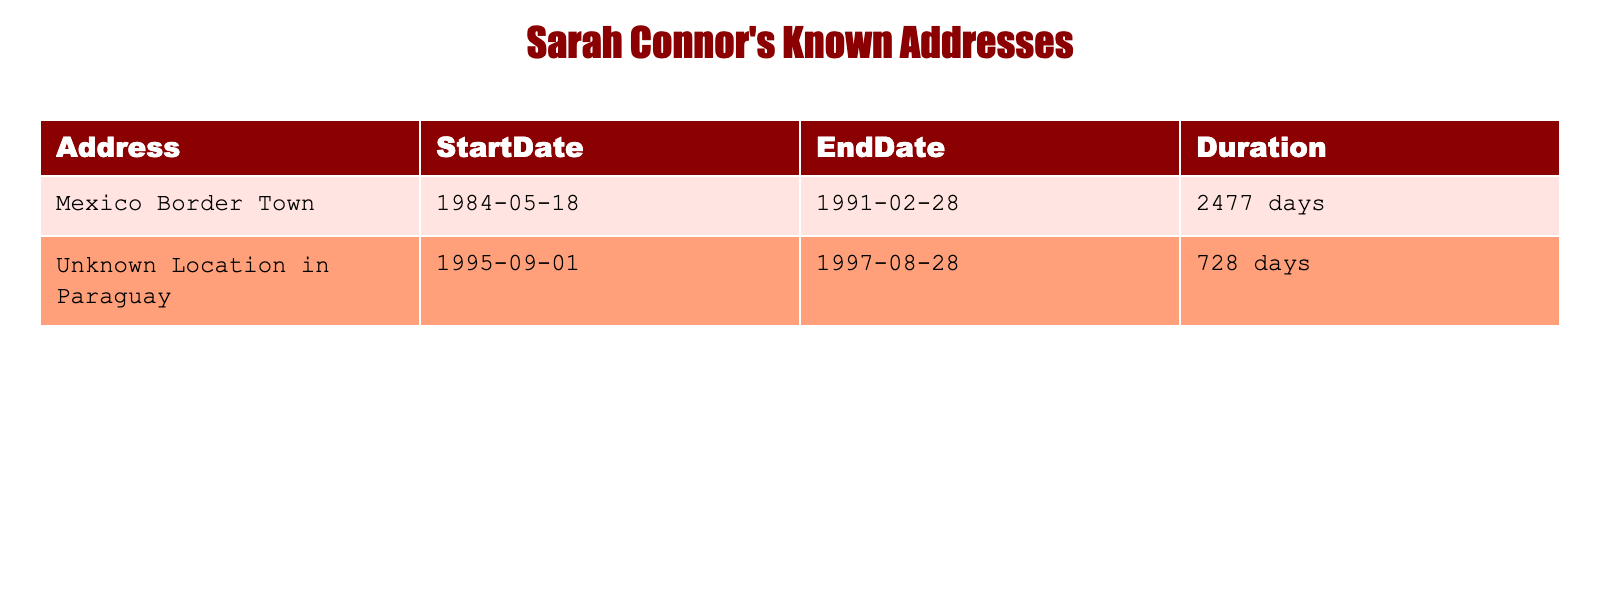What was the duration of Sarah Connor's stay at the Mexico Border Town? The table shows that her stay at the Mexico Border Town lasted for 2477 days.
Answer: 2477 days Where did Sarah Connor stay from September 1, 1995, to August 28, 1997? According to the table, Sarah Connor stayed at an Unknown Location in Paraguay during that time period.
Answer: Unknown Location in Paraguay How many total days did Sarah Connor spend in her known addresses? To find the total duration, we add the durations: 2477 days (Mexico Border Town) + 728 days (Unknown Location in Paraguay) = 3205 days.
Answer: 3205 days Did Sarah Connor stay in any location for more than 2000 days? The duration at the Mexico Border Town was 2477 days, which is more than 2000 days. Therefore, the answer is yes.
Answer: Yes What is the difference in duration between Sarah Connor's stays at the two locations? The difference in days can be calculated by subtracting the shorter duration from the longer one: 2477 days - 728 days = 1749 days.
Answer: 1749 days Was the Unknown Location in Paraguay where Sarah Connor stayed longer than the Mexico Border Town? The duration in Paraguay was 728 days, while at the Mexico Border Town it was 2477 days. Since 728 days is less than 2477 days, the answer is no.
Answer: No Which location did Sarah Connor stay at the earliest? The table indicates that Sarah Connor started staying at the Mexico Border Town on May 18, 1984, which is earlier than her stay in Paraguay starting September 1, 1995.
Answer: Mexico Border Town How long did Sarah Connor stay in locations after the year 1990? The only address listed after 1990 is the Unknown Location in Paraguay, where she stayed for 728 days from 1995 to 1997.
Answer: 728 days 